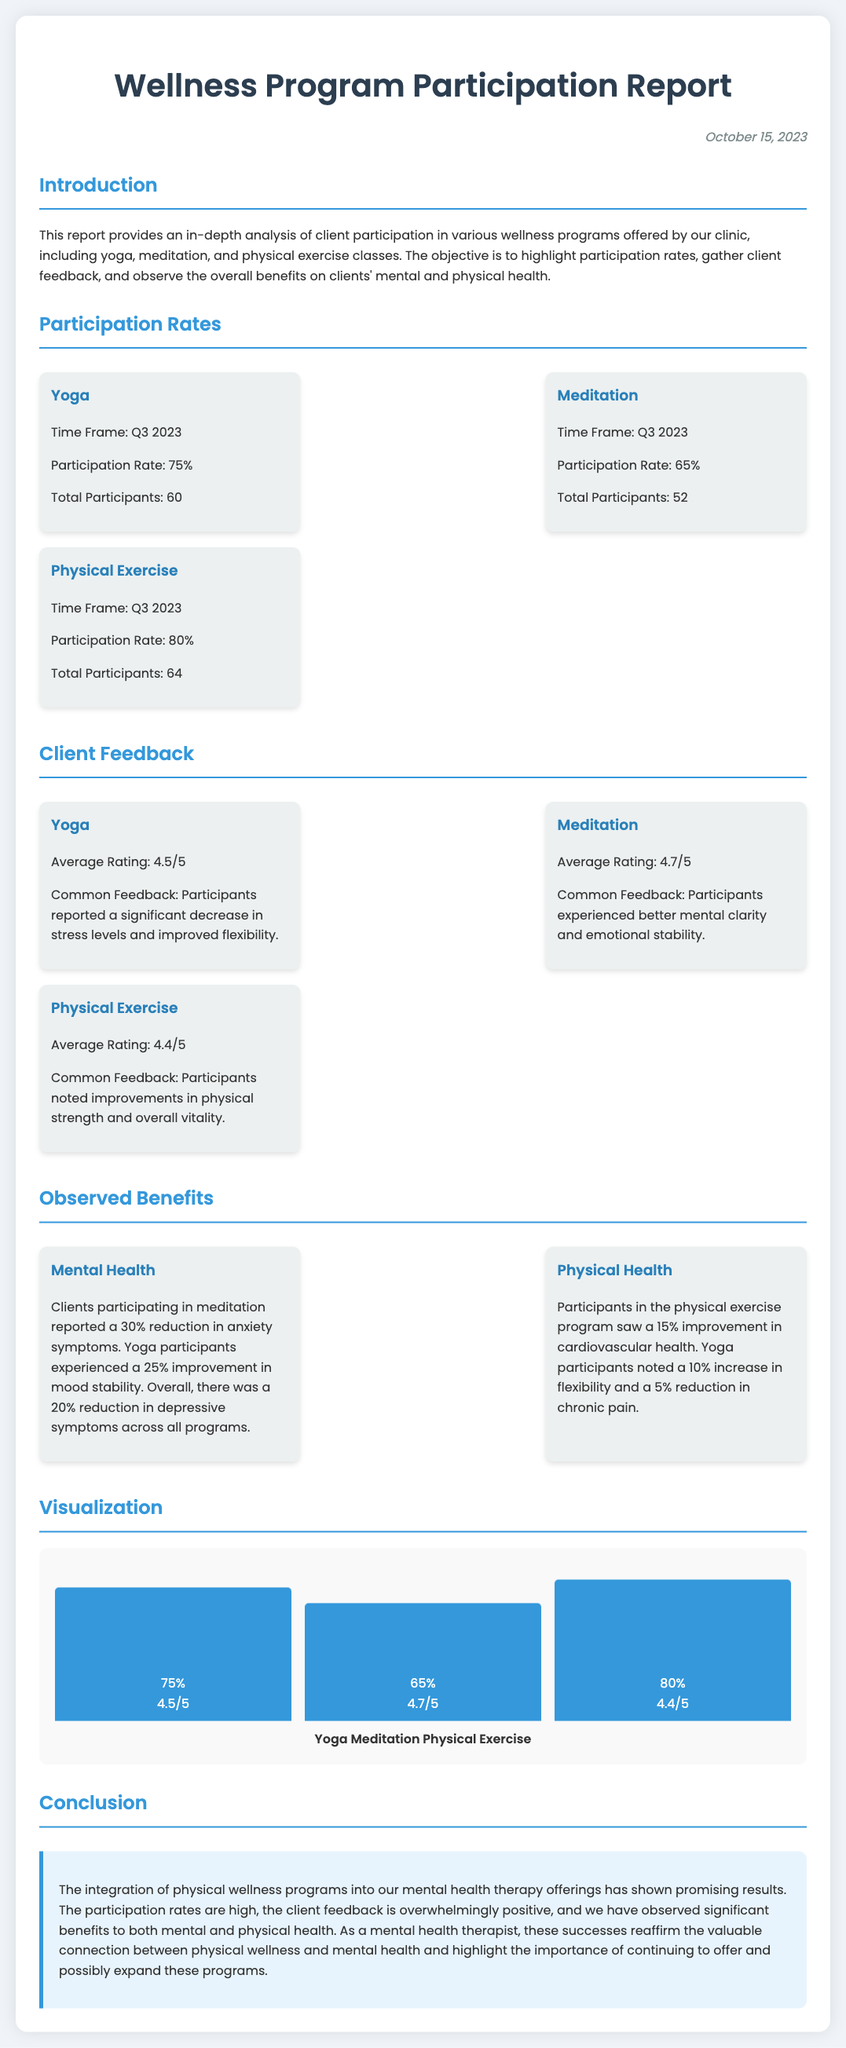What is the date of the report? The date of the report is mentioned at the top of the document.
Answer: October 15, 2023 What is the participation rate for yoga? The participation rate for yoga is specified under the Participation Rates section.
Answer: 75% What was the average rating for meditation? The average rating for meditation is included in the Client Feedback section.
Answer: 4.7/5 What percentage reduction in anxiety symptoms did meditation participants report? This information is seen in the Observed Benefits section, specifically regarding mental health.
Answer: 30% Which program had the highest total participants? The total participants for each program are stated, and this question requires comparing those numbers.
Answer: Physical Exercise What improvement in cardiovascular health was noted by exercise participants? The observed benefits for physical health are listed in the Observed Benefits section.
Answer: 15% How many total participants joined the meditation program? The total participants for the meditation program can be found in the Participation Rates section.
Answer: 52 What feedback did yoga participants commonly report? Common feedback from yoga participants is outlined in the Client Feedback section.
Answer: Significant decrease in stress levels and improved flexibility What is the purpose of the report? The purpose of the report is described in the introduction.
Answer: To highlight participation rates, gather client feedback, and observe the overall benefits 